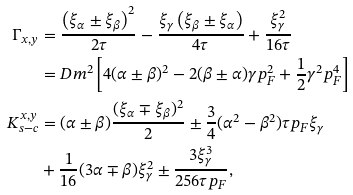<formula> <loc_0><loc_0><loc_500><loc_500>\Gamma _ { x , y } & = \frac { \left ( \xi _ { \alpha } \pm \xi _ { \beta } \right ) ^ { 2 } } { 2 \tau } - \frac { \xi _ { \gamma } \left ( \xi _ { \beta } \pm \xi _ { \alpha } \right ) } { 4 \tau } + \frac { \xi _ { \gamma } ^ { 2 } } { 1 6 \tau } \\ & = D m ^ { 2 } \left [ 4 ( \alpha \pm \beta ) ^ { 2 } - 2 ( \beta \pm \alpha ) \gamma p _ { F } ^ { 2 } + \frac { 1 } { 2 } \gamma ^ { 2 } p _ { F } ^ { 4 } \right ] \\ K _ { s - c } ^ { x , y } & = ( \alpha \pm \beta ) \frac { ( \xi _ { \alpha } \mp \xi _ { \beta } ) ^ { 2 } } { 2 } \pm \frac { 3 } { 4 } ( \alpha ^ { 2 } - \beta ^ { 2 } ) \tau p _ { F } \xi _ { \gamma } \\ & + \frac { 1 } { 1 6 } ( 3 \alpha \mp \beta ) \xi _ { \gamma } ^ { 2 } \pm \frac { 3 \xi _ { \gamma } ^ { 3 } } { 2 5 6 \tau p _ { F } } ,</formula> 